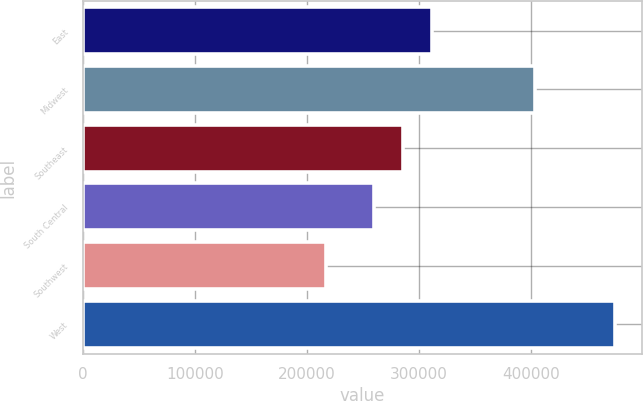Convert chart to OTSL. <chart><loc_0><loc_0><loc_500><loc_500><bar_chart><fcel>East<fcel>Midwest<fcel>Southeast<fcel>South Central<fcel>Southwest<fcel>West<nl><fcel>311800<fcel>403900<fcel>286000<fcel>260200<fcel>217200<fcel>475200<nl></chart> 